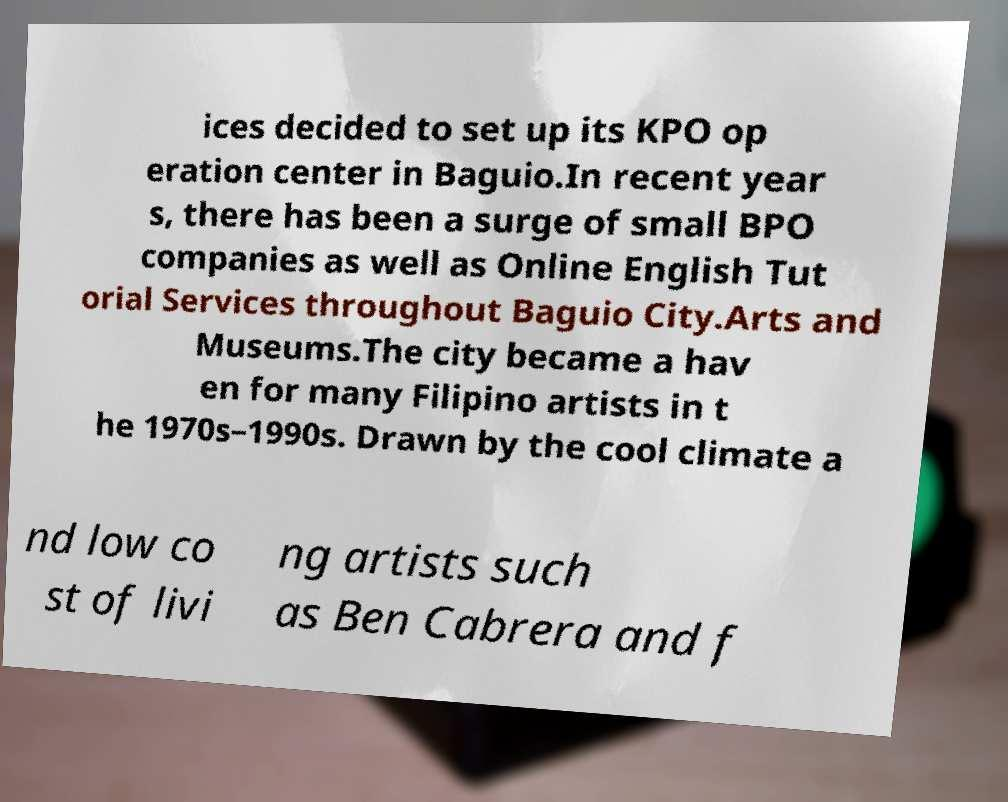Please read and relay the text visible in this image. What does it say? ices decided to set up its KPO op eration center in Baguio.In recent year s, there has been a surge of small BPO companies as well as Online English Tut orial Services throughout Baguio City.Arts and Museums.The city became a hav en for many Filipino artists in t he 1970s–1990s. Drawn by the cool climate a nd low co st of livi ng artists such as Ben Cabrera and f 